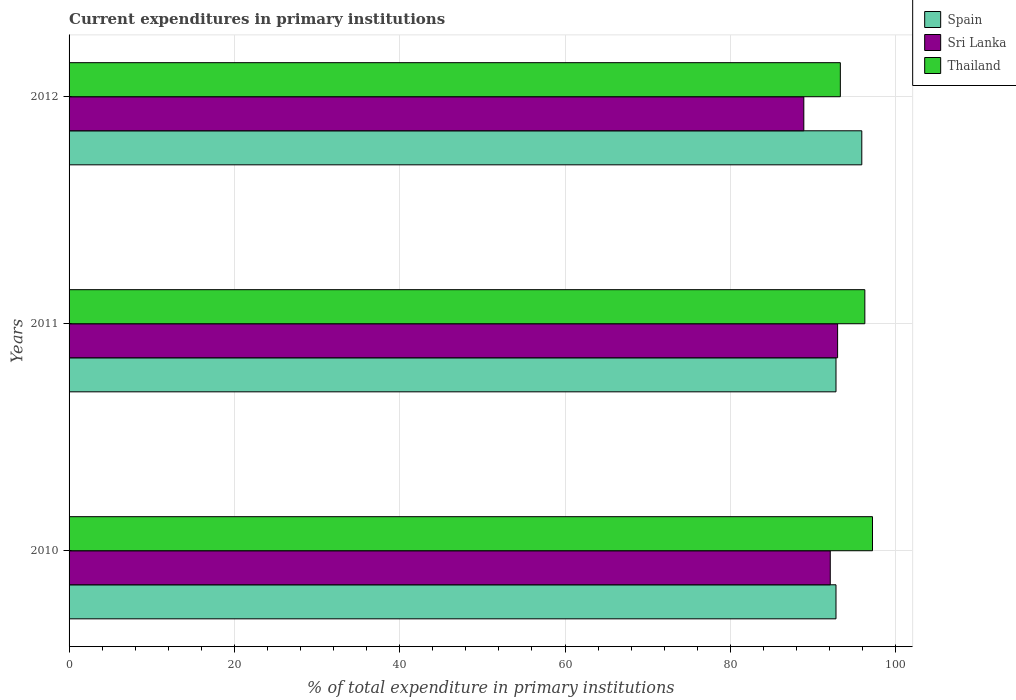How many bars are there on the 2nd tick from the top?
Make the answer very short. 3. What is the current expenditures in primary institutions in Sri Lanka in 2011?
Provide a succinct answer. 92.98. Across all years, what is the maximum current expenditures in primary institutions in Thailand?
Your answer should be very brief. 97.2. Across all years, what is the minimum current expenditures in primary institutions in Spain?
Give a very brief answer. 92.79. In which year was the current expenditures in primary institutions in Spain maximum?
Keep it short and to the point. 2012. In which year was the current expenditures in primary institutions in Sri Lanka minimum?
Provide a succinct answer. 2012. What is the total current expenditures in primary institutions in Thailand in the graph?
Provide a succinct answer. 286.79. What is the difference between the current expenditures in primary institutions in Sri Lanka in 2010 and that in 2011?
Offer a terse response. -0.89. What is the difference between the current expenditures in primary institutions in Thailand in 2010 and the current expenditures in primary institutions in Sri Lanka in 2012?
Give a very brief answer. 8.31. What is the average current expenditures in primary institutions in Spain per year?
Offer a very short reply. 93.83. In the year 2011, what is the difference between the current expenditures in primary institutions in Sri Lanka and current expenditures in primary institutions in Thailand?
Your answer should be compact. -3.29. In how many years, is the current expenditures in primary institutions in Spain greater than 20 %?
Keep it short and to the point. 3. What is the ratio of the current expenditures in primary institutions in Sri Lanka in 2011 to that in 2012?
Your answer should be very brief. 1.05. What is the difference between the highest and the second highest current expenditures in primary institutions in Sri Lanka?
Ensure brevity in your answer.  0.89. What is the difference between the highest and the lowest current expenditures in primary institutions in Spain?
Make the answer very short. 3.12. What does the 1st bar from the top in 2011 represents?
Offer a terse response. Thailand. What does the 2nd bar from the bottom in 2010 represents?
Provide a succinct answer. Sri Lanka. Is it the case that in every year, the sum of the current expenditures in primary institutions in Thailand and current expenditures in primary institutions in Spain is greater than the current expenditures in primary institutions in Sri Lanka?
Give a very brief answer. Yes. Are all the bars in the graph horizontal?
Provide a succinct answer. Yes. How many years are there in the graph?
Offer a very short reply. 3. What is the difference between two consecutive major ticks on the X-axis?
Provide a succinct answer. 20. Does the graph contain grids?
Make the answer very short. Yes. Where does the legend appear in the graph?
Offer a terse response. Top right. How many legend labels are there?
Your answer should be very brief. 3. How are the legend labels stacked?
Provide a short and direct response. Vertical. What is the title of the graph?
Ensure brevity in your answer.  Current expenditures in primary institutions. What is the label or title of the X-axis?
Your answer should be compact. % of total expenditure in primary institutions. What is the label or title of the Y-axis?
Your response must be concise. Years. What is the % of total expenditure in primary institutions in Spain in 2010?
Give a very brief answer. 92.79. What is the % of total expenditure in primary institutions of Sri Lanka in 2010?
Offer a very short reply. 92.09. What is the % of total expenditure in primary institutions of Thailand in 2010?
Offer a terse response. 97.2. What is the % of total expenditure in primary institutions of Spain in 2011?
Give a very brief answer. 92.79. What is the % of total expenditure in primary institutions in Sri Lanka in 2011?
Your answer should be very brief. 92.98. What is the % of total expenditure in primary institutions of Thailand in 2011?
Your answer should be very brief. 96.28. What is the % of total expenditure in primary institutions of Spain in 2012?
Your response must be concise. 95.91. What is the % of total expenditure in primary institutions in Sri Lanka in 2012?
Keep it short and to the point. 88.89. What is the % of total expenditure in primary institutions of Thailand in 2012?
Your response must be concise. 93.31. Across all years, what is the maximum % of total expenditure in primary institutions of Spain?
Give a very brief answer. 95.91. Across all years, what is the maximum % of total expenditure in primary institutions of Sri Lanka?
Keep it short and to the point. 92.98. Across all years, what is the maximum % of total expenditure in primary institutions of Thailand?
Provide a short and direct response. 97.2. Across all years, what is the minimum % of total expenditure in primary institutions of Spain?
Offer a terse response. 92.79. Across all years, what is the minimum % of total expenditure in primary institutions in Sri Lanka?
Provide a short and direct response. 88.89. Across all years, what is the minimum % of total expenditure in primary institutions of Thailand?
Your answer should be compact. 93.31. What is the total % of total expenditure in primary institutions of Spain in the graph?
Ensure brevity in your answer.  281.48. What is the total % of total expenditure in primary institutions in Sri Lanka in the graph?
Your answer should be compact. 273.97. What is the total % of total expenditure in primary institutions of Thailand in the graph?
Make the answer very short. 286.79. What is the difference between the % of total expenditure in primary institutions of Sri Lanka in 2010 and that in 2011?
Your response must be concise. -0.89. What is the difference between the % of total expenditure in primary institutions of Thailand in 2010 and that in 2011?
Your answer should be very brief. 0.93. What is the difference between the % of total expenditure in primary institutions of Spain in 2010 and that in 2012?
Ensure brevity in your answer.  -3.12. What is the difference between the % of total expenditure in primary institutions in Sri Lanka in 2010 and that in 2012?
Provide a succinct answer. 3.2. What is the difference between the % of total expenditure in primary institutions of Thailand in 2010 and that in 2012?
Give a very brief answer. 3.89. What is the difference between the % of total expenditure in primary institutions in Spain in 2011 and that in 2012?
Your answer should be compact. -3.12. What is the difference between the % of total expenditure in primary institutions in Sri Lanka in 2011 and that in 2012?
Give a very brief answer. 4.09. What is the difference between the % of total expenditure in primary institutions in Thailand in 2011 and that in 2012?
Ensure brevity in your answer.  2.96. What is the difference between the % of total expenditure in primary institutions of Spain in 2010 and the % of total expenditure in primary institutions of Sri Lanka in 2011?
Make the answer very short. -0.19. What is the difference between the % of total expenditure in primary institutions of Spain in 2010 and the % of total expenditure in primary institutions of Thailand in 2011?
Your answer should be compact. -3.49. What is the difference between the % of total expenditure in primary institutions in Sri Lanka in 2010 and the % of total expenditure in primary institutions in Thailand in 2011?
Your answer should be very brief. -4.18. What is the difference between the % of total expenditure in primary institutions in Spain in 2010 and the % of total expenditure in primary institutions in Sri Lanka in 2012?
Keep it short and to the point. 3.89. What is the difference between the % of total expenditure in primary institutions in Spain in 2010 and the % of total expenditure in primary institutions in Thailand in 2012?
Make the answer very short. -0.53. What is the difference between the % of total expenditure in primary institutions of Sri Lanka in 2010 and the % of total expenditure in primary institutions of Thailand in 2012?
Offer a terse response. -1.22. What is the difference between the % of total expenditure in primary institutions of Spain in 2011 and the % of total expenditure in primary institutions of Sri Lanka in 2012?
Provide a succinct answer. 3.89. What is the difference between the % of total expenditure in primary institutions in Spain in 2011 and the % of total expenditure in primary institutions in Thailand in 2012?
Give a very brief answer. -0.53. What is the difference between the % of total expenditure in primary institutions in Sri Lanka in 2011 and the % of total expenditure in primary institutions in Thailand in 2012?
Offer a very short reply. -0.33. What is the average % of total expenditure in primary institutions of Spain per year?
Offer a terse response. 93.83. What is the average % of total expenditure in primary institutions of Sri Lanka per year?
Provide a short and direct response. 91.32. What is the average % of total expenditure in primary institutions of Thailand per year?
Offer a very short reply. 95.6. In the year 2010, what is the difference between the % of total expenditure in primary institutions in Spain and % of total expenditure in primary institutions in Sri Lanka?
Provide a short and direct response. 0.69. In the year 2010, what is the difference between the % of total expenditure in primary institutions in Spain and % of total expenditure in primary institutions in Thailand?
Make the answer very short. -4.42. In the year 2010, what is the difference between the % of total expenditure in primary institutions of Sri Lanka and % of total expenditure in primary institutions of Thailand?
Make the answer very short. -5.11. In the year 2011, what is the difference between the % of total expenditure in primary institutions in Spain and % of total expenditure in primary institutions in Sri Lanka?
Keep it short and to the point. -0.19. In the year 2011, what is the difference between the % of total expenditure in primary institutions in Spain and % of total expenditure in primary institutions in Thailand?
Keep it short and to the point. -3.49. In the year 2011, what is the difference between the % of total expenditure in primary institutions in Sri Lanka and % of total expenditure in primary institutions in Thailand?
Make the answer very short. -3.29. In the year 2012, what is the difference between the % of total expenditure in primary institutions in Spain and % of total expenditure in primary institutions in Sri Lanka?
Your response must be concise. 7.02. In the year 2012, what is the difference between the % of total expenditure in primary institutions in Spain and % of total expenditure in primary institutions in Thailand?
Give a very brief answer. 2.6. In the year 2012, what is the difference between the % of total expenditure in primary institutions in Sri Lanka and % of total expenditure in primary institutions in Thailand?
Ensure brevity in your answer.  -4.42. What is the ratio of the % of total expenditure in primary institutions in Spain in 2010 to that in 2011?
Make the answer very short. 1. What is the ratio of the % of total expenditure in primary institutions in Sri Lanka in 2010 to that in 2011?
Offer a very short reply. 0.99. What is the ratio of the % of total expenditure in primary institutions of Thailand in 2010 to that in 2011?
Your response must be concise. 1.01. What is the ratio of the % of total expenditure in primary institutions of Spain in 2010 to that in 2012?
Your answer should be compact. 0.97. What is the ratio of the % of total expenditure in primary institutions of Sri Lanka in 2010 to that in 2012?
Your answer should be compact. 1.04. What is the ratio of the % of total expenditure in primary institutions in Thailand in 2010 to that in 2012?
Provide a short and direct response. 1.04. What is the ratio of the % of total expenditure in primary institutions of Spain in 2011 to that in 2012?
Your response must be concise. 0.97. What is the ratio of the % of total expenditure in primary institutions of Sri Lanka in 2011 to that in 2012?
Offer a very short reply. 1.05. What is the ratio of the % of total expenditure in primary institutions in Thailand in 2011 to that in 2012?
Provide a succinct answer. 1.03. What is the difference between the highest and the second highest % of total expenditure in primary institutions in Spain?
Ensure brevity in your answer.  3.12. What is the difference between the highest and the second highest % of total expenditure in primary institutions in Sri Lanka?
Your answer should be compact. 0.89. What is the difference between the highest and the second highest % of total expenditure in primary institutions in Thailand?
Your response must be concise. 0.93. What is the difference between the highest and the lowest % of total expenditure in primary institutions in Spain?
Make the answer very short. 3.12. What is the difference between the highest and the lowest % of total expenditure in primary institutions of Sri Lanka?
Make the answer very short. 4.09. What is the difference between the highest and the lowest % of total expenditure in primary institutions of Thailand?
Offer a very short reply. 3.89. 